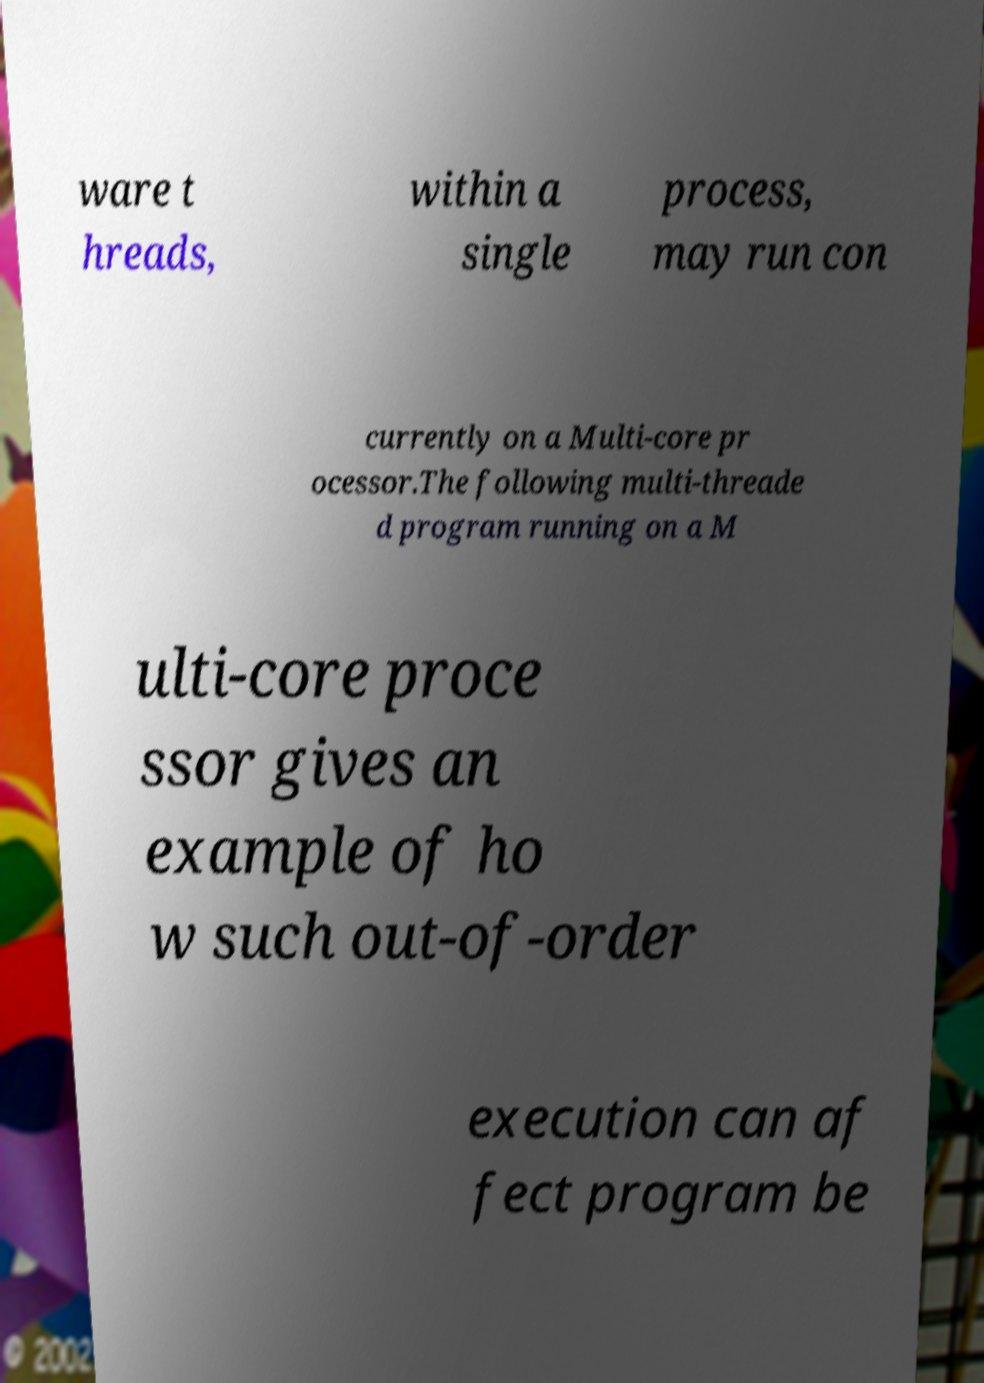I need the written content from this picture converted into text. Can you do that? ware t hreads, within a single process, may run con currently on a Multi-core pr ocessor.The following multi-threade d program running on a M ulti-core proce ssor gives an example of ho w such out-of-order execution can af fect program be 